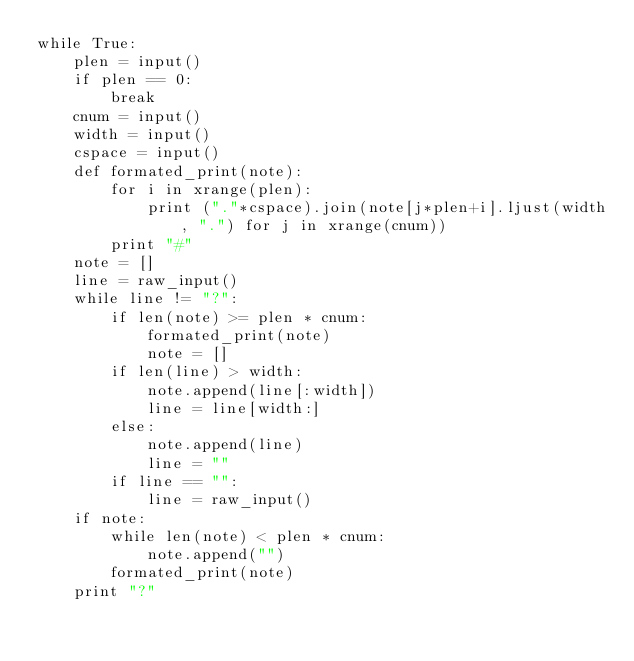Convert code to text. <code><loc_0><loc_0><loc_500><loc_500><_Python_>while True:
    plen = input()
    if plen == 0:
        break
    cnum = input()
    width = input()
    cspace = input()
    def formated_print(note):
        for i in xrange(plen):
            print ("."*cspace).join(note[j*plen+i].ljust(width, ".") for j in xrange(cnum))
        print "#"
    note = []
    line = raw_input()
    while line != "?":
        if len(note) >= plen * cnum:
            formated_print(note)
            note = []
        if len(line) > width:
            note.append(line[:width])            
            line = line[width:]
        else:
            note.append(line)
            line = ""
        if line == "":
            line = raw_input()
    if note:
        while len(note) < plen * cnum:
            note.append("")    
        formated_print(note)
    print "?"</code> 